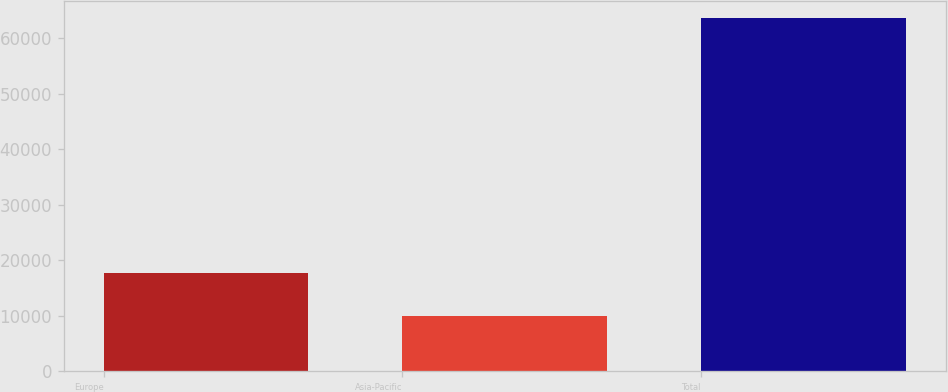Convert chart to OTSL. <chart><loc_0><loc_0><loc_500><loc_500><bar_chart><fcel>Europe<fcel>Asia-Pacific<fcel>Total<nl><fcel>17755<fcel>9929<fcel>63584<nl></chart> 